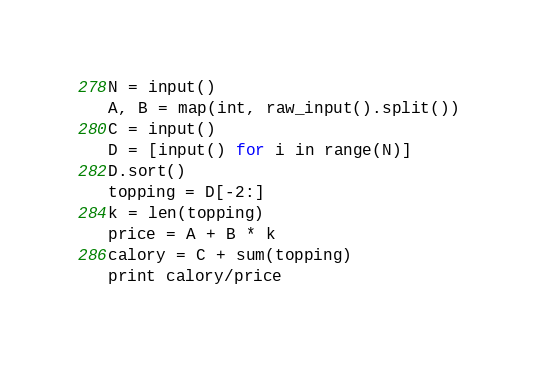Convert code to text. <code><loc_0><loc_0><loc_500><loc_500><_Python_>N = input()
A, B = map(int, raw_input().split())
C = input()
D = [input() for i in range(N)]
D.sort()
topping = D[-2:]
k = len(topping)
price = A + B * k
calory = C + sum(topping)
print calory/price</code> 